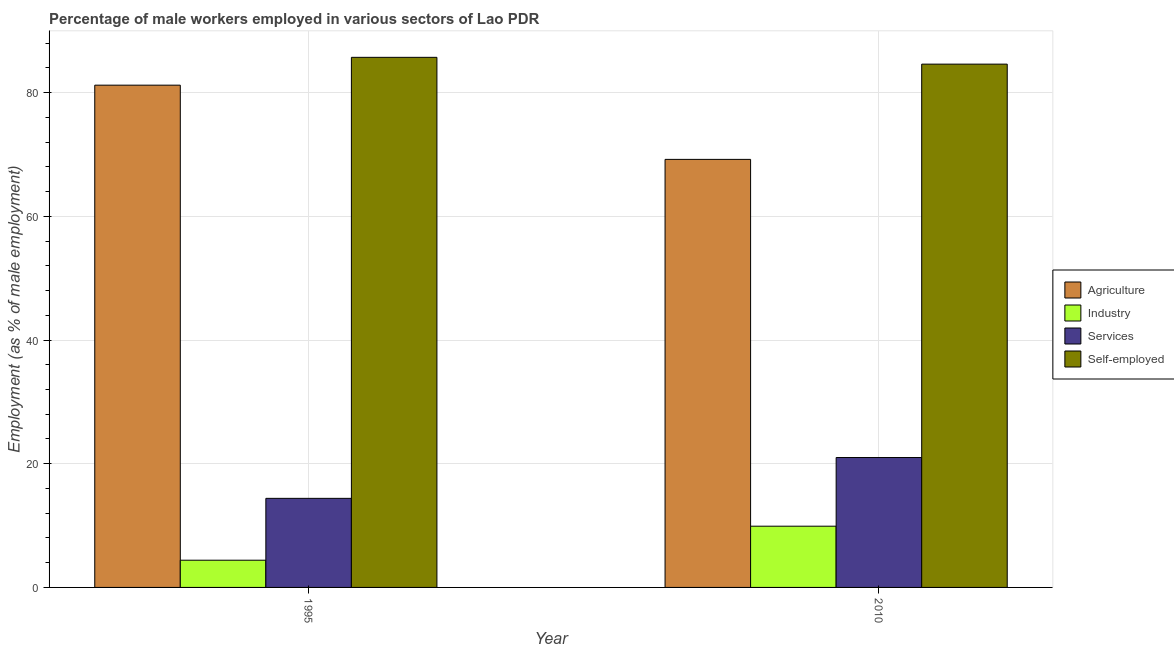How many groups of bars are there?
Ensure brevity in your answer.  2. Are the number of bars per tick equal to the number of legend labels?
Provide a short and direct response. Yes. Are the number of bars on each tick of the X-axis equal?
Make the answer very short. Yes. How many bars are there on the 2nd tick from the left?
Offer a terse response. 4. What is the label of the 2nd group of bars from the left?
Make the answer very short. 2010. In how many cases, is the number of bars for a given year not equal to the number of legend labels?
Your response must be concise. 0. What is the percentage of male workers in services in 1995?
Provide a short and direct response. 14.4. Across all years, what is the maximum percentage of self employed male workers?
Your answer should be compact. 85.7. Across all years, what is the minimum percentage of male workers in industry?
Give a very brief answer. 4.4. In which year was the percentage of self employed male workers minimum?
Ensure brevity in your answer.  2010. What is the total percentage of male workers in services in the graph?
Your answer should be compact. 35.4. What is the difference between the percentage of self employed male workers in 1995 and that in 2010?
Make the answer very short. 1.1. What is the difference between the percentage of male workers in services in 2010 and the percentage of male workers in industry in 1995?
Give a very brief answer. 6.6. What is the average percentage of self employed male workers per year?
Keep it short and to the point. 85.15. What is the ratio of the percentage of male workers in services in 1995 to that in 2010?
Ensure brevity in your answer.  0.69. Is it the case that in every year, the sum of the percentage of male workers in services and percentage of male workers in agriculture is greater than the sum of percentage of self employed male workers and percentage of male workers in industry?
Keep it short and to the point. No. What does the 3rd bar from the left in 2010 represents?
Your answer should be very brief. Services. What does the 1st bar from the right in 1995 represents?
Ensure brevity in your answer.  Self-employed. How many years are there in the graph?
Provide a succinct answer. 2. What is the difference between two consecutive major ticks on the Y-axis?
Your response must be concise. 20. Are the values on the major ticks of Y-axis written in scientific E-notation?
Offer a very short reply. No. How are the legend labels stacked?
Keep it short and to the point. Vertical. What is the title of the graph?
Provide a succinct answer. Percentage of male workers employed in various sectors of Lao PDR. What is the label or title of the X-axis?
Keep it short and to the point. Year. What is the label or title of the Y-axis?
Give a very brief answer. Employment (as % of male employment). What is the Employment (as % of male employment) of Agriculture in 1995?
Ensure brevity in your answer.  81.2. What is the Employment (as % of male employment) in Industry in 1995?
Provide a succinct answer. 4.4. What is the Employment (as % of male employment) in Services in 1995?
Your answer should be very brief. 14.4. What is the Employment (as % of male employment) of Self-employed in 1995?
Your response must be concise. 85.7. What is the Employment (as % of male employment) of Agriculture in 2010?
Provide a succinct answer. 69.2. What is the Employment (as % of male employment) of Industry in 2010?
Keep it short and to the point. 9.9. What is the Employment (as % of male employment) of Self-employed in 2010?
Provide a succinct answer. 84.6. Across all years, what is the maximum Employment (as % of male employment) in Agriculture?
Your answer should be compact. 81.2. Across all years, what is the maximum Employment (as % of male employment) of Industry?
Your response must be concise. 9.9. Across all years, what is the maximum Employment (as % of male employment) of Services?
Keep it short and to the point. 21. Across all years, what is the maximum Employment (as % of male employment) of Self-employed?
Your answer should be very brief. 85.7. Across all years, what is the minimum Employment (as % of male employment) of Agriculture?
Your answer should be very brief. 69.2. Across all years, what is the minimum Employment (as % of male employment) in Industry?
Your answer should be compact. 4.4. Across all years, what is the minimum Employment (as % of male employment) of Services?
Offer a very short reply. 14.4. Across all years, what is the minimum Employment (as % of male employment) in Self-employed?
Provide a succinct answer. 84.6. What is the total Employment (as % of male employment) in Agriculture in the graph?
Provide a short and direct response. 150.4. What is the total Employment (as % of male employment) in Services in the graph?
Offer a terse response. 35.4. What is the total Employment (as % of male employment) of Self-employed in the graph?
Your response must be concise. 170.3. What is the difference between the Employment (as % of male employment) in Services in 1995 and that in 2010?
Your answer should be very brief. -6.6. What is the difference between the Employment (as % of male employment) of Agriculture in 1995 and the Employment (as % of male employment) of Industry in 2010?
Your response must be concise. 71.3. What is the difference between the Employment (as % of male employment) in Agriculture in 1995 and the Employment (as % of male employment) in Services in 2010?
Ensure brevity in your answer.  60.2. What is the difference between the Employment (as % of male employment) of Industry in 1995 and the Employment (as % of male employment) of Services in 2010?
Keep it short and to the point. -16.6. What is the difference between the Employment (as % of male employment) of Industry in 1995 and the Employment (as % of male employment) of Self-employed in 2010?
Your answer should be very brief. -80.2. What is the difference between the Employment (as % of male employment) in Services in 1995 and the Employment (as % of male employment) in Self-employed in 2010?
Provide a succinct answer. -70.2. What is the average Employment (as % of male employment) of Agriculture per year?
Give a very brief answer. 75.2. What is the average Employment (as % of male employment) in Industry per year?
Your answer should be compact. 7.15. What is the average Employment (as % of male employment) of Services per year?
Give a very brief answer. 17.7. What is the average Employment (as % of male employment) of Self-employed per year?
Keep it short and to the point. 85.15. In the year 1995, what is the difference between the Employment (as % of male employment) of Agriculture and Employment (as % of male employment) of Industry?
Your response must be concise. 76.8. In the year 1995, what is the difference between the Employment (as % of male employment) in Agriculture and Employment (as % of male employment) in Services?
Your response must be concise. 66.8. In the year 1995, what is the difference between the Employment (as % of male employment) in Agriculture and Employment (as % of male employment) in Self-employed?
Your response must be concise. -4.5. In the year 1995, what is the difference between the Employment (as % of male employment) in Industry and Employment (as % of male employment) in Self-employed?
Your response must be concise. -81.3. In the year 1995, what is the difference between the Employment (as % of male employment) of Services and Employment (as % of male employment) of Self-employed?
Make the answer very short. -71.3. In the year 2010, what is the difference between the Employment (as % of male employment) of Agriculture and Employment (as % of male employment) of Industry?
Keep it short and to the point. 59.3. In the year 2010, what is the difference between the Employment (as % of male employment) in Agriculture and Employment (as % of male employment) in Services?
Keep it short and to the point. 48.2. In the year 2010, what is the difference between the Employment (as % of male employment) in Agriculture and Employment (as % of male employment) in Self-employed?
Your answer should be compact. -15.4. In the year 2010, what is the difference between the Employment (as % of male employment) in Industry and Employment (as % of male employment) in Services?
Make the answer very short. -11.1. In the year 2010, what is the difference between the Employment (as % of male employment) of Industry and Employment (as % of male employment) of Self-employed?
Make the answer very short. -74.7. In the year 2010, what is the difference between the Employment (as % of male employment) of Services and Employment (as % of male employment) of Self-employed?
Make the answer very short. -63.6. What is the ratio of the Employment (as % of male employment) of Agriculture in 1995 to that in 2010?
Provide a short and direct response. 1.17. What is the ratio of the Employment (as % of male employment) in Industry in 1995 to that in 2010?
Give a very brief answer. 0.44. What is the ratio of the Employment (as % of male employment) of Services in 1995 to that in 2010?
Keep it short and to the point. 0.69. What is the difference between the highest and the second highest Employment (as % of male employment) of Agriculture?
Give a very brief answer. 12. What is the difference between the highest and the second highest Employment (as % of male employment) in Industry?
Offer a very short reply. 5.5. What is the difference between the highest and the second highest Employment (as % of male employment) of Self-employed?
Provide a succinct answer. 1.1. What is the difference between the highest and the lowest Employment (as % of male employment) in Self-employed?
Provide a short and direct response. 1.1. 